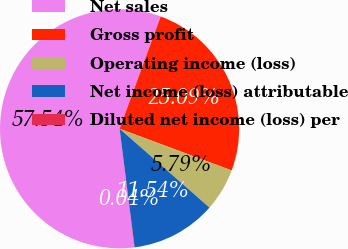Convert chart. <chart><loc_0><loc_0><loc_500><loc_500><pie_chart><fcel>Net sales<fcel>Gross profit<fcel>Operating income (loss)<fcel>Net income (loss) attributable<fcel>Diluted net income (loss) per<nl><fcel>57.55%<fcel>25.09%<fcel>5.79%<fcel>11.54%<fcel>0.04%<nl></chart> 